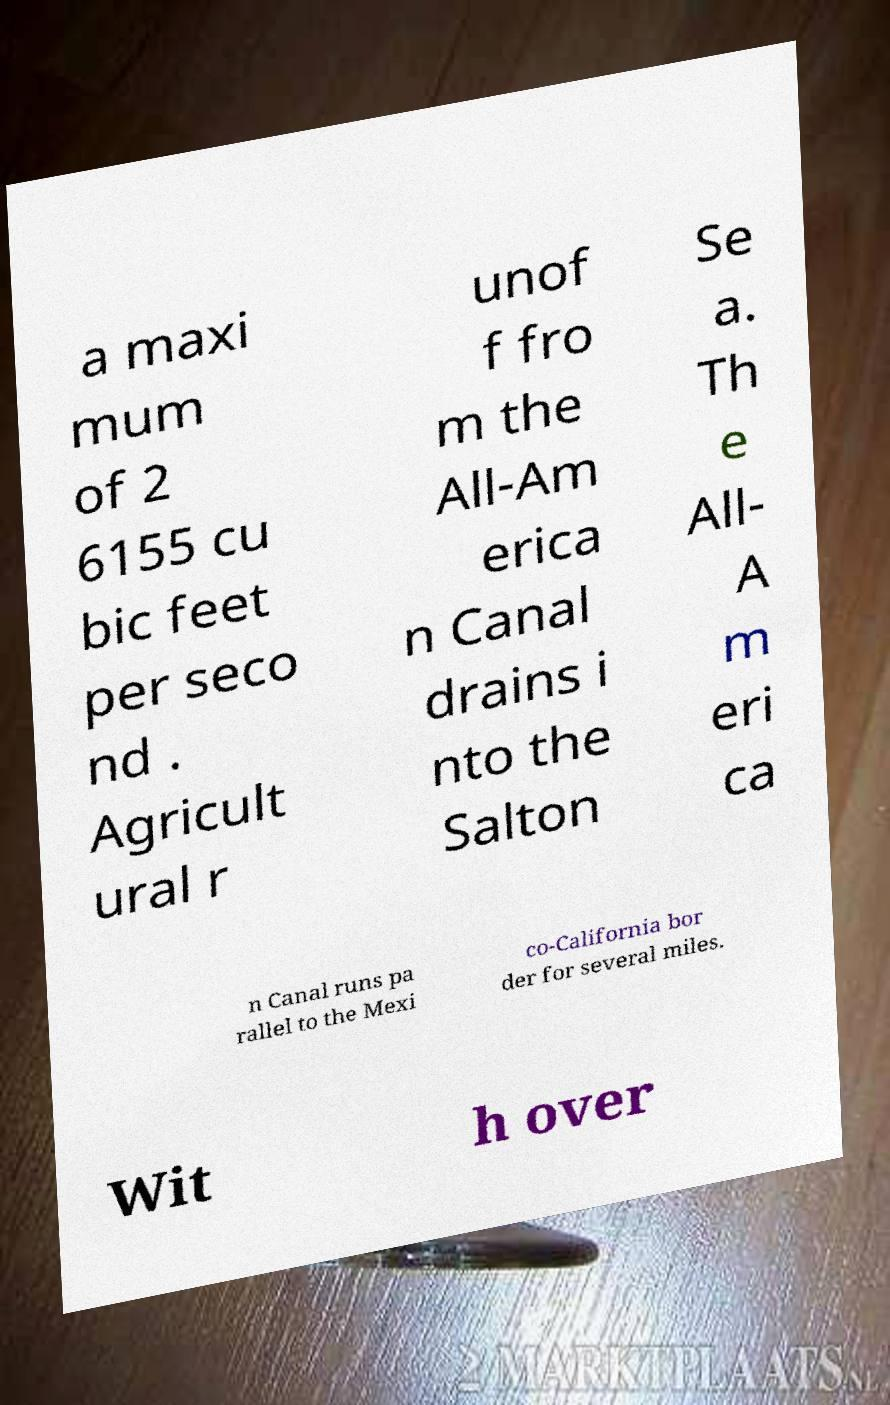For documentation purposes, I need the text within this image transcribed. Could you provide that? a maxi mum of 2 6155 cu bic feet per seco nd . Agricult ural r unof f fro m the All-Am erica n Canal drains i nto the Salton Se a. Th e All- A m eri ca n Canal runs pa rallel to the Mexi co-California bor der for several miles. Wit h over 